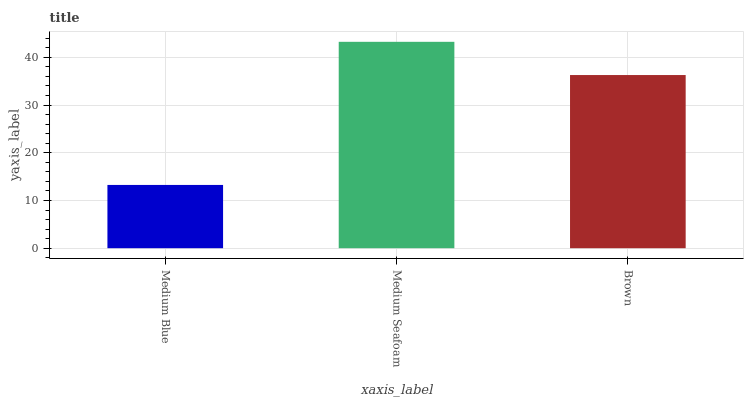Is Medium Blue the minimum?
Answer yes or no. Yes. Is Medium Seafoam the maximum?
Answer yes or no. Yes. Is Brown the minimum?
Answer yes or no. No. Is Brown the maximum?
Answer yes or no. No. Is Medium Seafoam greater than Brown?
Answer yes or no. Yes. Is Brown less than Medium Seafoam?
Answer yes or no. Yes. Is Brown greater than Medium Seafoam?
Answer yes or no. No. Is Medium Seafoam less than Brown?
Answer yes or no. No. Is Brown the high median?
Answer yes or no. Yes. Is Brown the low median?
Answer yes or no. Yes. Is Medium Blue the high median?
Answer yes or no. No. Is Medium Seafoam the low median?
Answer yes or no. No. 